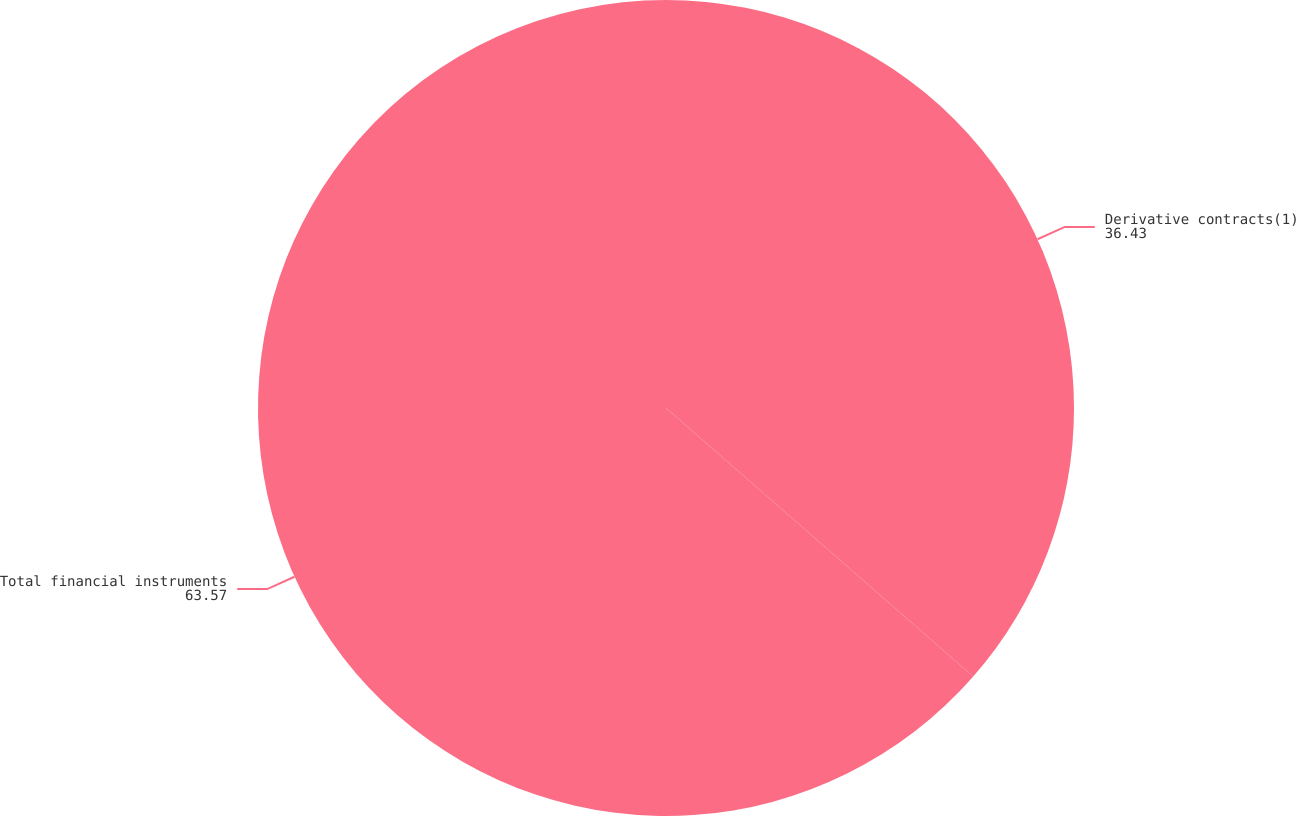Convert chart. <chart><loc_0><loc_0><loc_500><loc_500><pie_chart><fcel>Derivative contracts(1)<fcel>Total financial instruments<nl><fcel>36.43%<fcel>63.57%<nl></chart> 